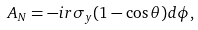<formula> <loc_0><loc_0><loc_500><loc_500>A _ { N } = - i r \sigma _ { y } ( 1 - \cos \theta ) d \phi ,</formula> 